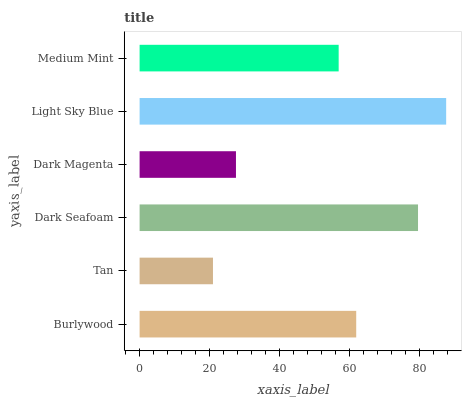Is Tan the minimum?
Answer yes or no. Yes. Is Light Sky Blue the maximum?
Answer yes or no. Yes. Is Dark Seafoam the minimum?
Answer yes or no. No. Is Dark Seafoam the maximum?
Answer yes or no. No. Is Dark Seafoam greater than Tan?
Answer yes or no. Yes. Is Tan less than Dark Seafoam?
Answer yes or no. Yes. Is Tan greater than Dark Seafoam?
Answer yes or no. No. Is Dark Seafoam less than Tan?
Answer yes or no. No. Is Burlywood the high median?
Answer yes or no. Yes. Is Medium Mint the low median?
Answer yes or no. Yes. Is Dark Magenta the high median?
Answer yes or no. No. Is Dark Magenta the low median?
Answer yes or no. No. 